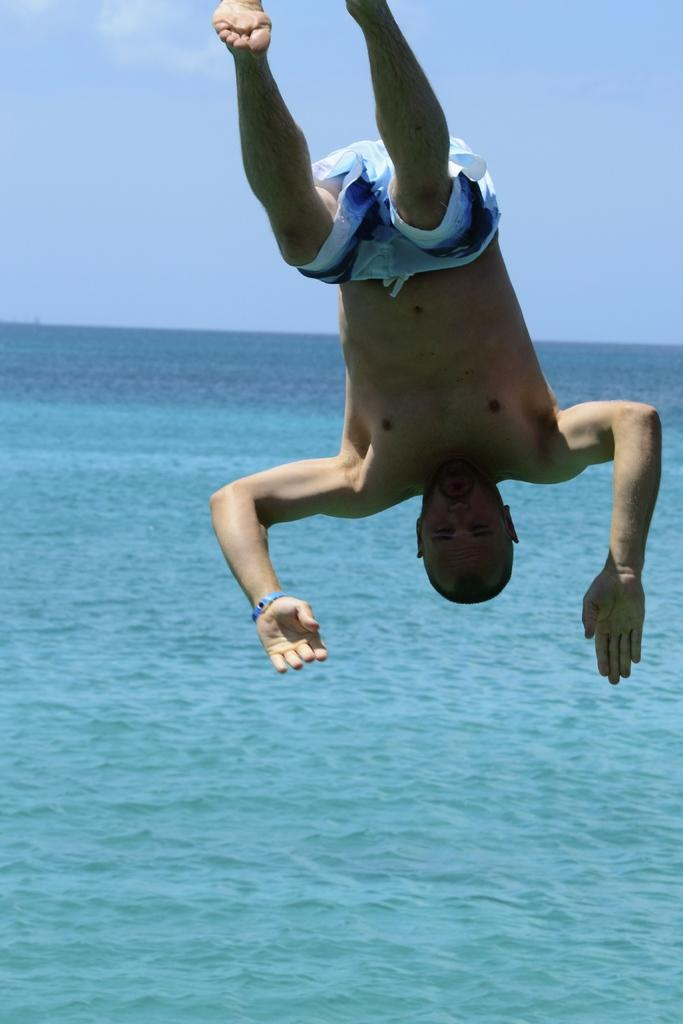What is located in the middle of the image? There is water in the middle of the image. What can be seen at the top of the image? The sky is visible at the top of the image. What is the person in the image doing? The person is jumping into the water. How many sticks are floating in the water in the image? There are no sticks present in the image. Are there any goldfish visible in the water in the image? There are no goldfish present in the image. 